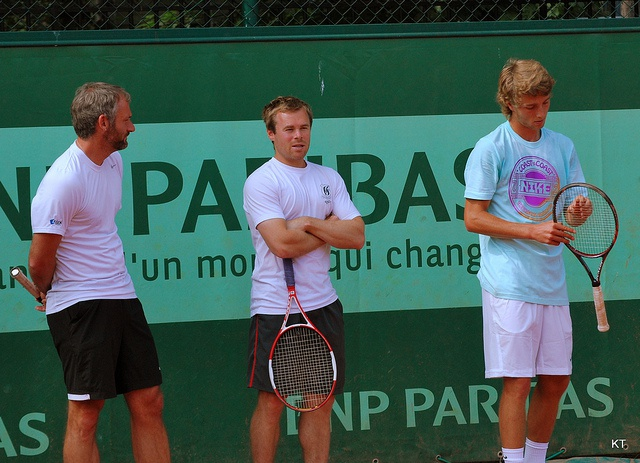Describe the objects in this image and their specific colors. I can see people in black, darkgray, gray, maroon, and lightblue tones, people in black, lavender, and brown tones, people in black, darkgray, maroon, and violet tones, tennis racket in black, gray, and maroon tones, and tennis racket in black, teal, gray, and brown tones in this image. 